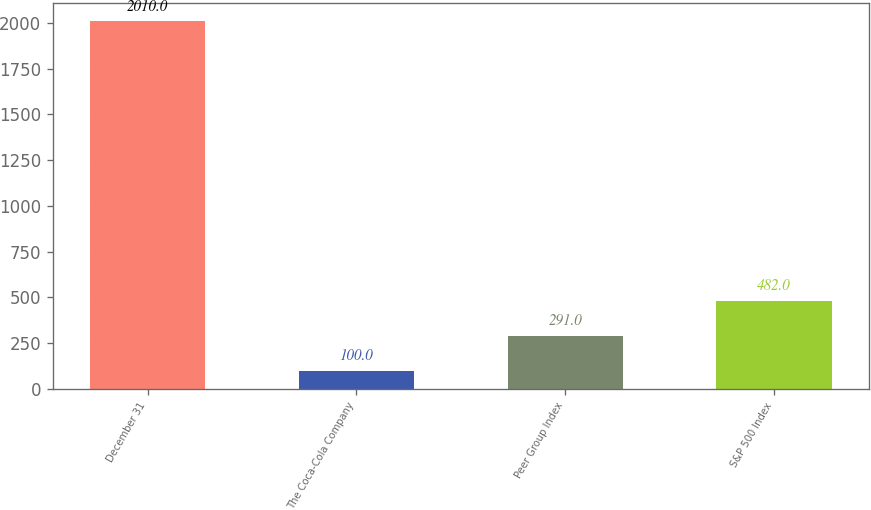Convert chart. <chart><loc_0><loc_0><loc_500><loc_500><bar_chart><fcel>December 31<fcel>The Coca-Cola Company<fcel>Peer Group Index<fcel>S&P 500 Index<nl><fcel>2010<fcel>100<fcel>291<fcel>482<nl></chart> 